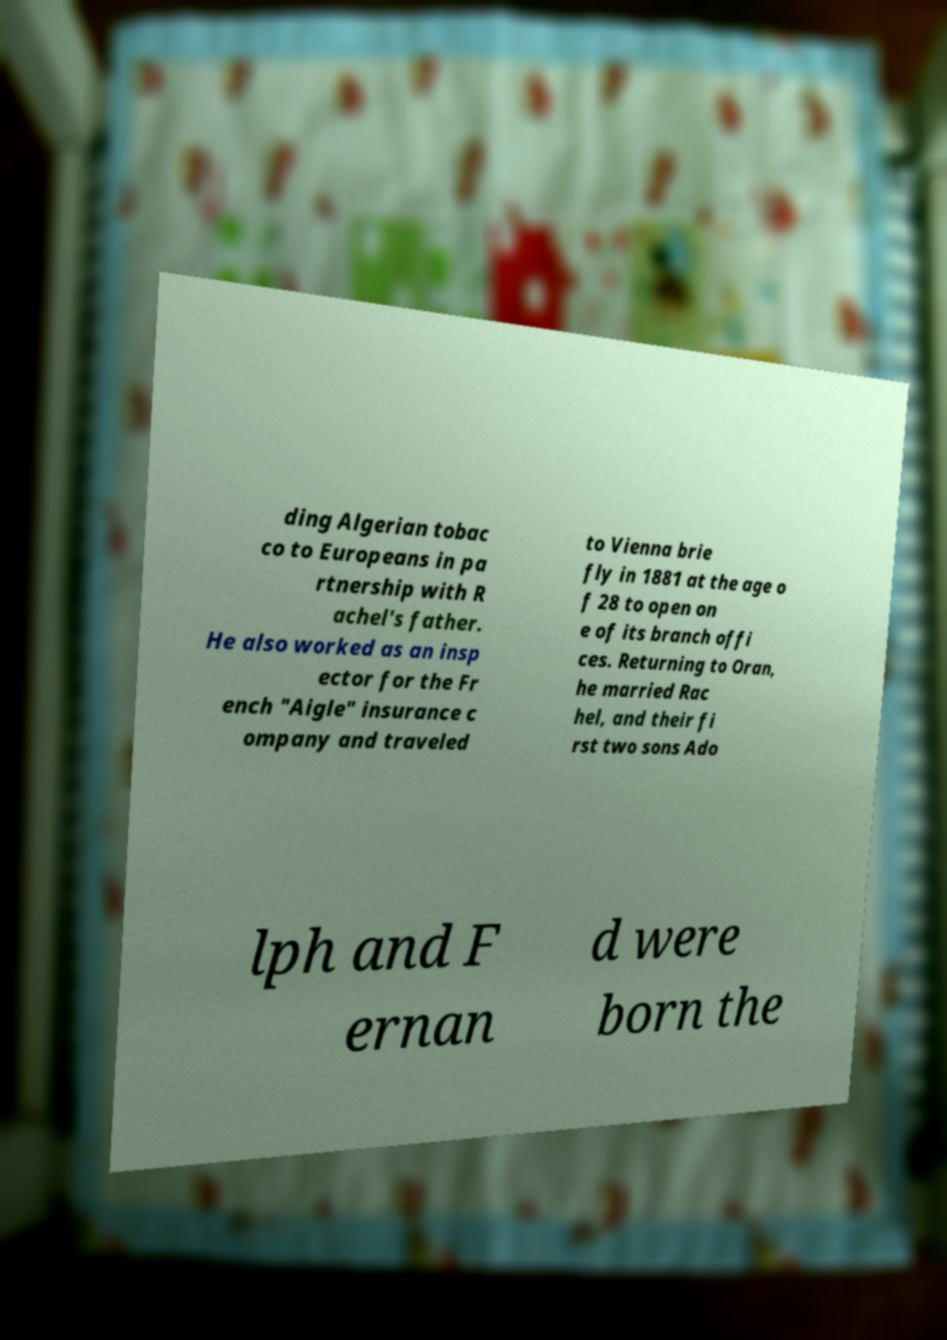Could you extract and type out the text from this image? ding Algerian tobac co to Europeans in pa rtnership with R achel's father. He also worked as an insp ector for the Fr ench "Aigle" insurance c ompany and traveled to Vienna brie fly in 1881 at the age o f 28 to open on e of its branch offi ces. Returning to Oran, he married Rac hel, and their fi rst two sons Ado lph and F ernan d were born the 